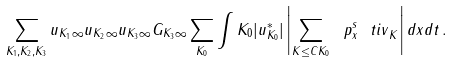Convert formula to latex. <formula><loc_0><loc_0><loc_500><loc_500>\sum _ { K _ { 1 } , K _ { 2 } , K _ { 3 } } \| u _ { K _ { 1 } } \| _ { \infty } \| u _ { K _ { 2 } } \| _ { \infty } \| u _ { K _ { 3 } } \| _ { \infty } \| G _ { K _ { 3 } } \| _ { \infty } \sum _ { K _ { 0 } } \int K _ { 0 } | u ^ { * } _ { K _ { 0 } } | \left | \sum _ { K \leq C K _ { 0 } } { \ p _ { x } ^ { s } \ t i v } _ { K } \right | d x d t \, .</formula> 